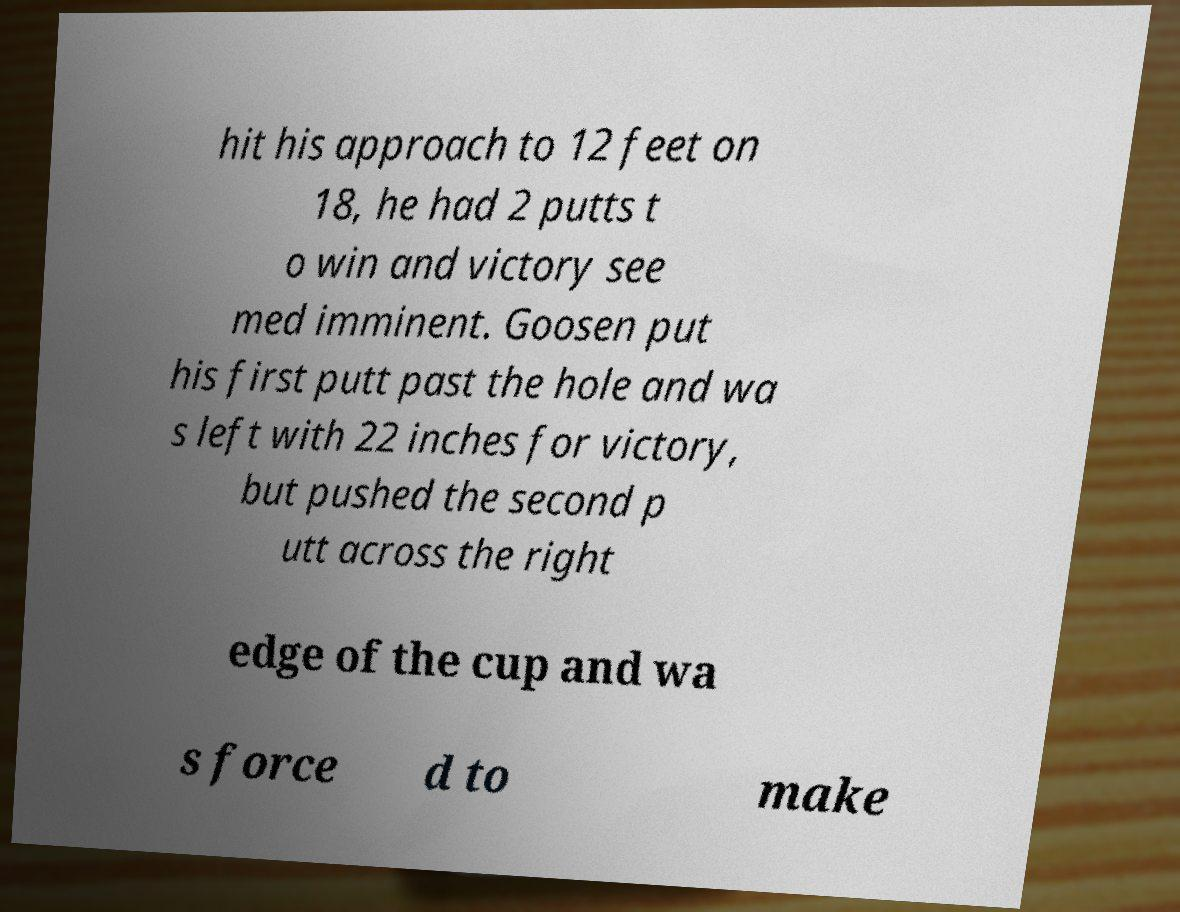Please identify and transcribe the text found in this image. hit his approach to 12 feet on 18, he had 2 putts t o win and victory see med imminent. Goosen put his first putt past the hole and wa s left with 22 inches for victory, but pushed the second p utt across the right edge of the cup and wa s force d to make 